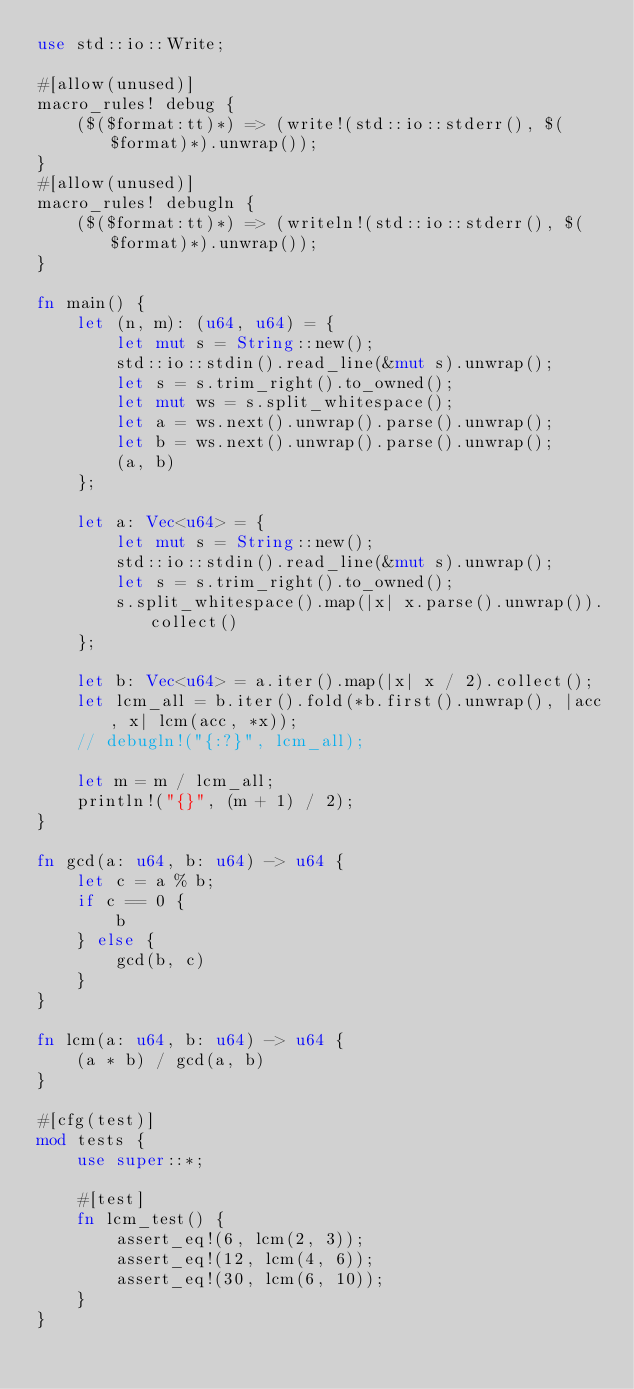Convert code to text. <code><loc_0><loc_0><loc_500><loc_500><_Rust_>use std::io::Write;

#[allow(unused)]
macro_rules! debug {
    ($($format:tt)*) => (write!(std::io::stderr(), $($format)*).unwrap());
}
#[allow(unused)]
macro_rules! debugln {
    ($($format:tt)*) => (writeln!(std::io::stderr(), $($format)*).unwrap());
}

fn main() {
    let (n, m): (u64, u64) = {
        let mut s = String::new();
        std::io::stdin().read_line(&mut s).unwrap();
        let s = s.trim_right().to_owned();
        let mut ws = s.split_whitespace();
        let a = ws.next().unwrap().parse().unwrap();
        let b = ws.next().unwrap().parse().unwrap();
        (a, b)
    };

    let a: Vec<u64> = {
        let mut s = String::new();
        std::io::stdin().read_line(&mut s).unwrap();
        let s = s.trim_right().to_owned();
        s.split_whitespace().map(|x| x.parse().unwrap()).collect()
    };

    let b: Vec<u64> = a.iter().map(|x| x / 2).collect();
    let lcm_all = b.iter().fold(*b.first().unwrap(), |acc, x| lcm(acc, *x));
    // debugln!("{:?}", lcm_all);

    let m = m / lcm_all;
    println!("{}", (m + 1) / 2);
}

fn gcd(a: u64, b: u64) -> u64 {
    let c = a % b;
    if c == 0 {
        b
    } else {
        gcd(b, c)
    }
}

fn lcm(a: u64, b: u64) -> u64 {
    (a * b) / gcd(a, b)
}

#[cfg(test)]
mod tests {
    use super::*;

    #[test]
    fn lcm_test() {
        assert_eq!(6, lcm(2, 3));
        assert_eq!(12, lcm(4, 6));
        assert_eq!(30, lcm(6, 10));
    }
}
</code> 